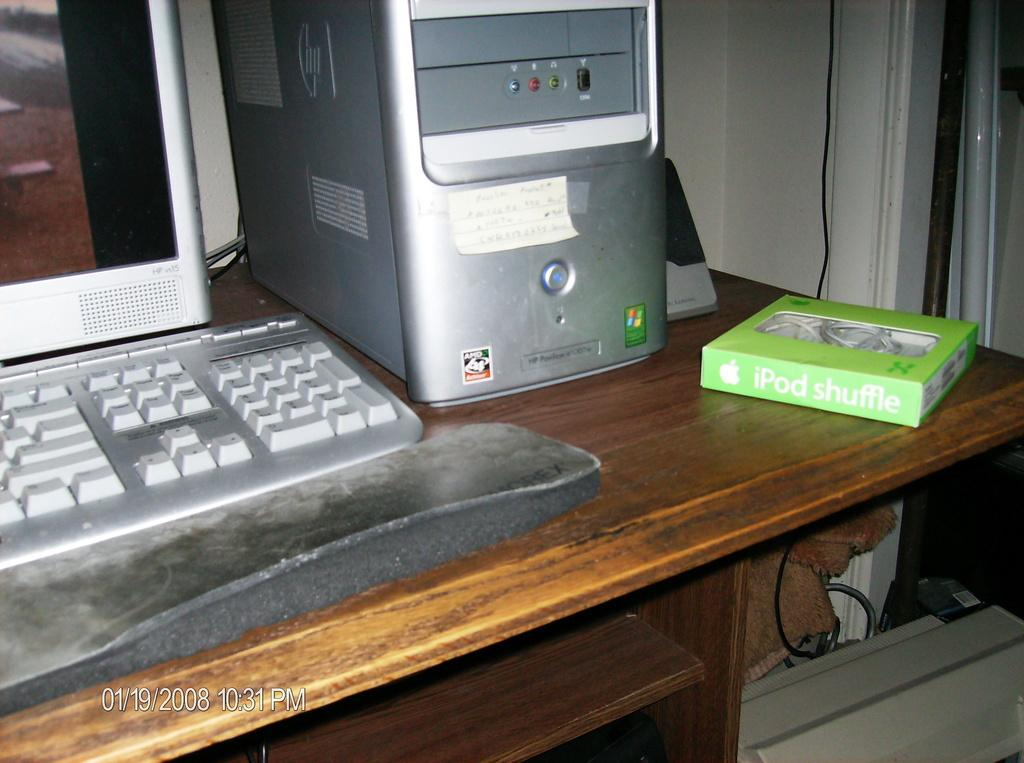<image>
Create a compact narrative representing the image presented. Green iPod Shuffle box next to a desktop PC. 